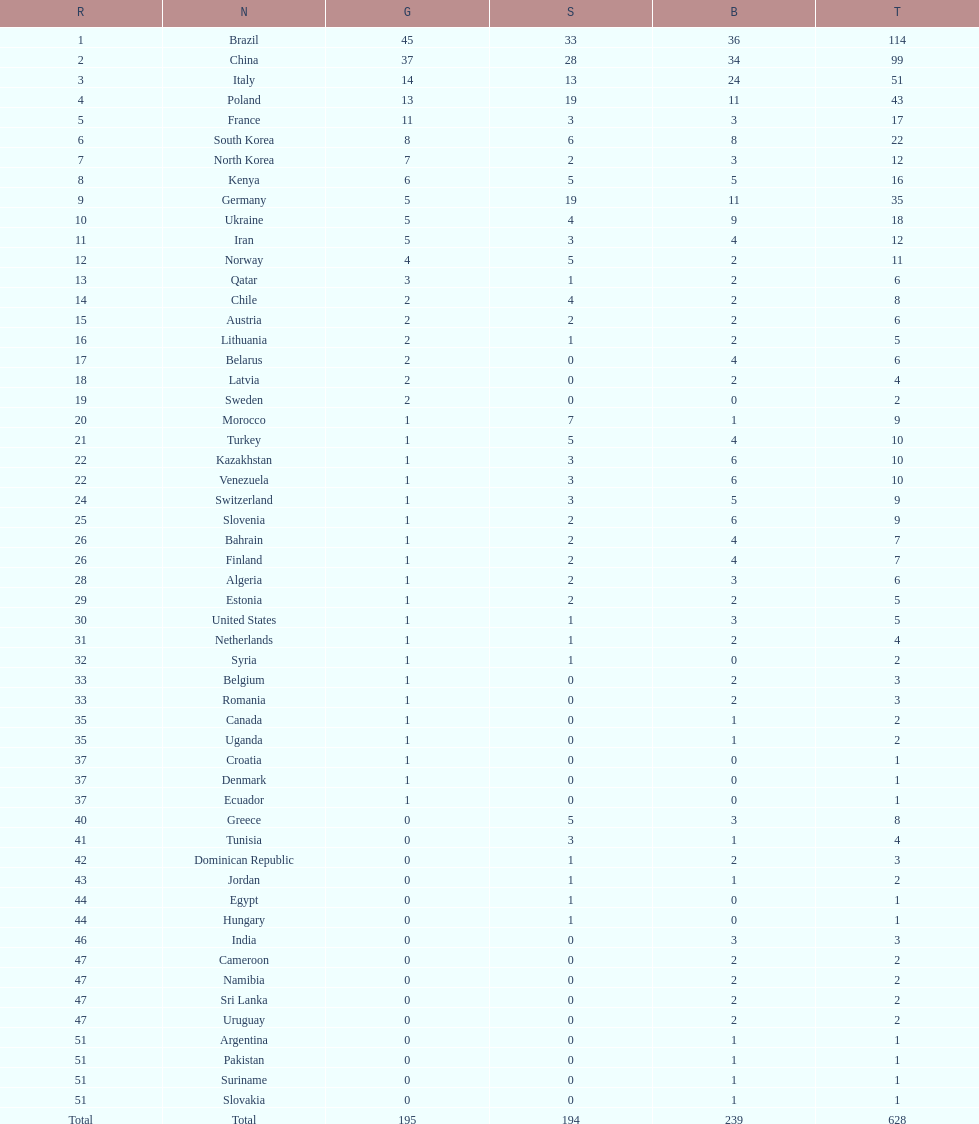Which type of medal does belarus not have? Silver. 